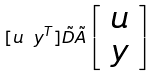<formula> <loc_0><loc_0><loc_500><loc_500>[ u \ y ^ { T } ] \tilde { D } \tilde { A } \left [ \begin{array} { c } u \\ y \end{array} \right ]</formula> 